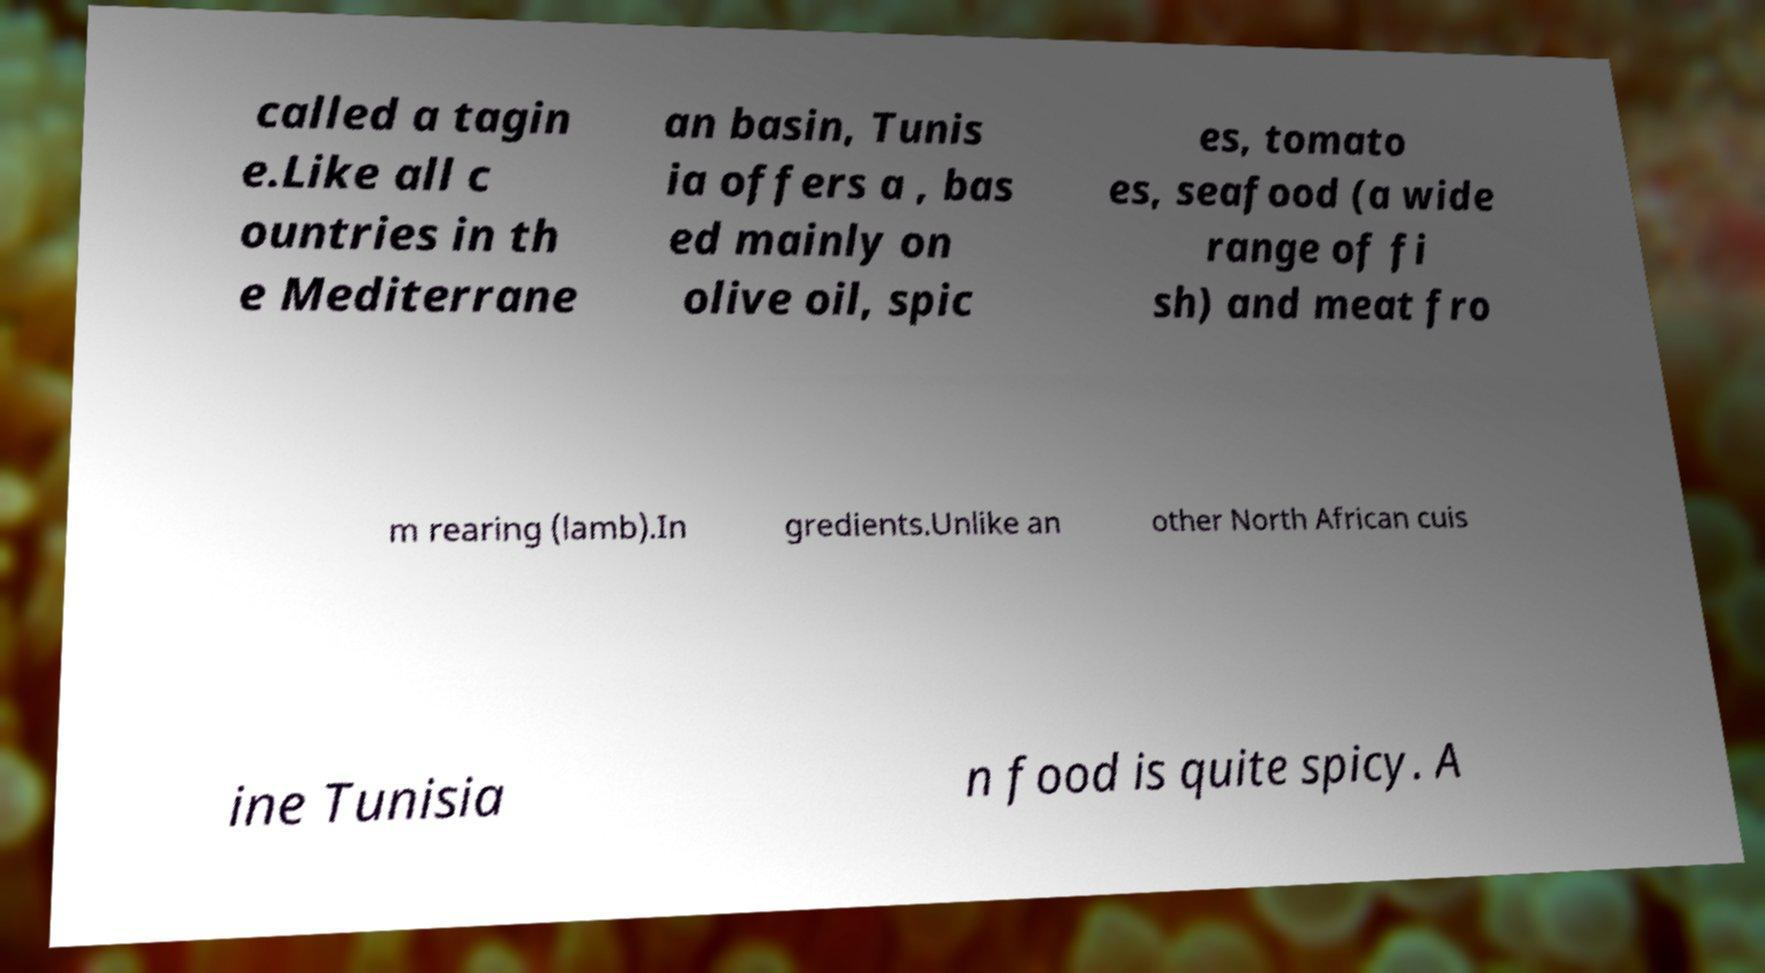For documentation purposes, I need the text within this image transcribed. Could you provide that? called a tagin e.Like all c ountries in th e Mediterrane an basin, Tunis ia offers a , bas ed mainly on olive oil, spic es, tomato es, seafood (a wide range of fi sh) and meat fro m rearing (lamb).In gredients.Unlike an other North African cuis ine Tunisia n food is quite spicy. A 